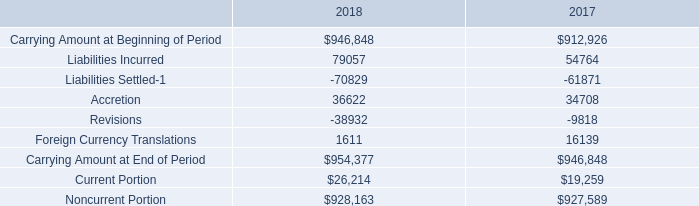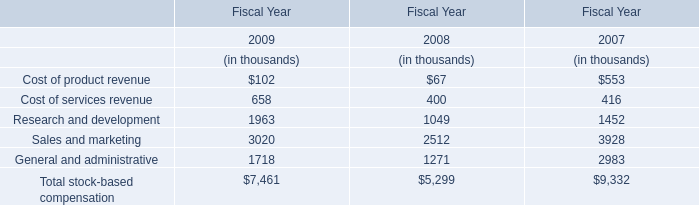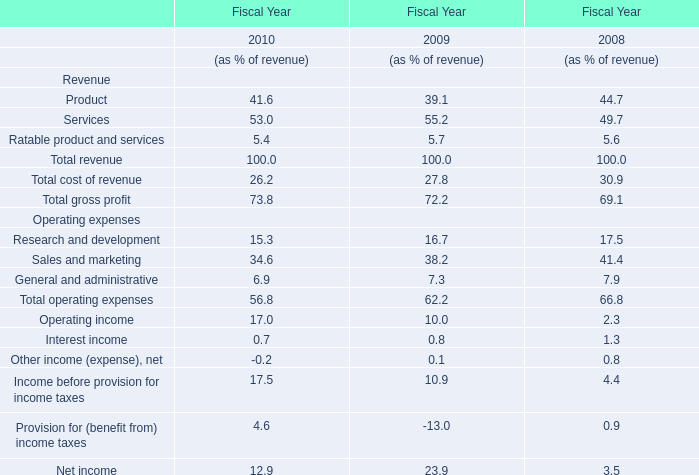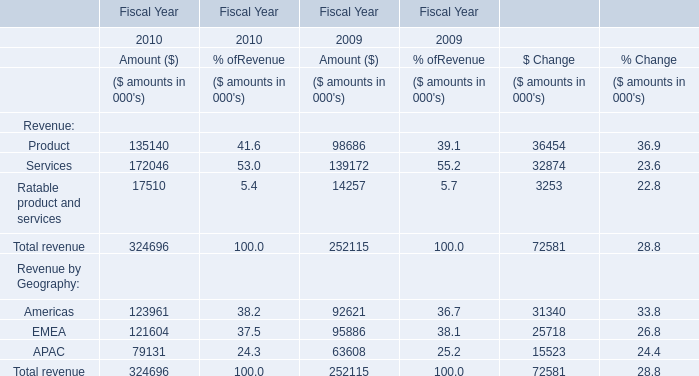what is the increase observed in the liabilities incurred during 2017 and 2018? 
Computations: ((79057 / 54764) - 1)
Answer: 0.44359. 